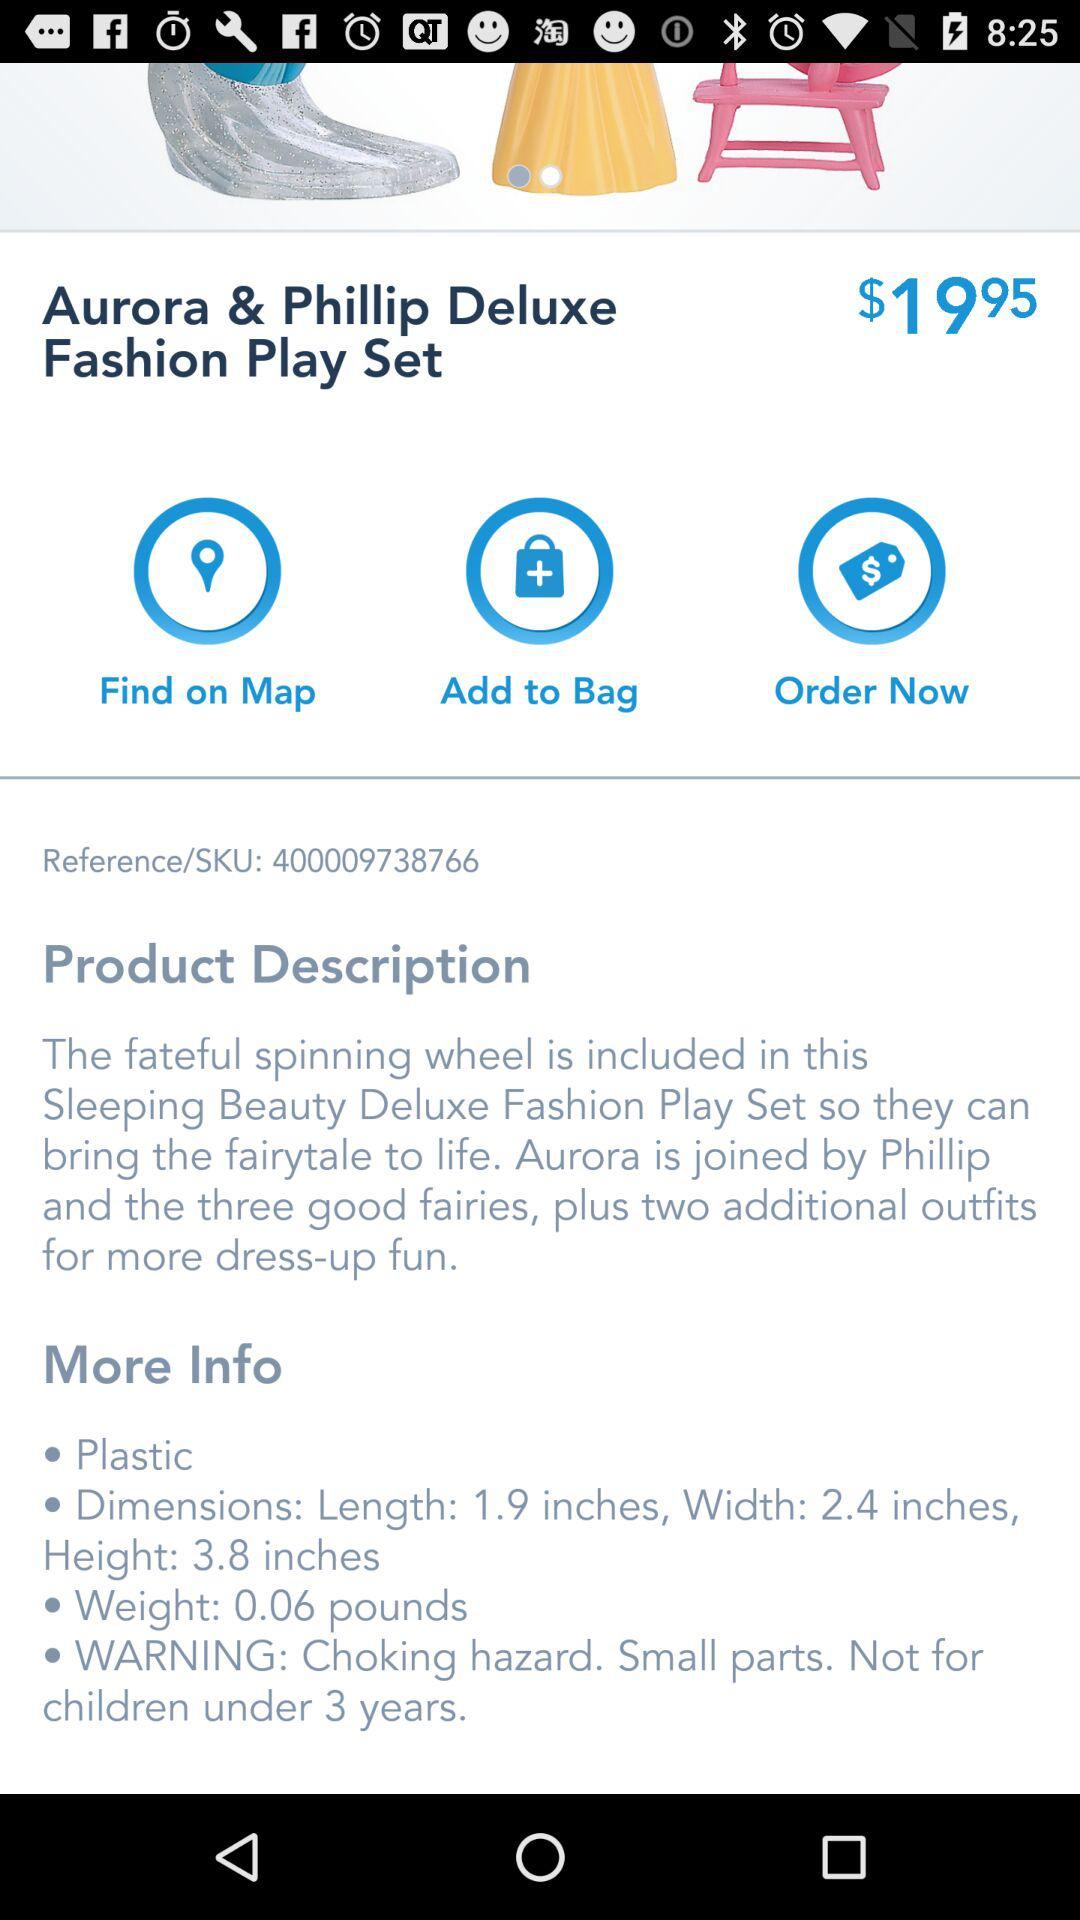How many inches is the length of the play set? The length of the play set is 1.9 inches. 